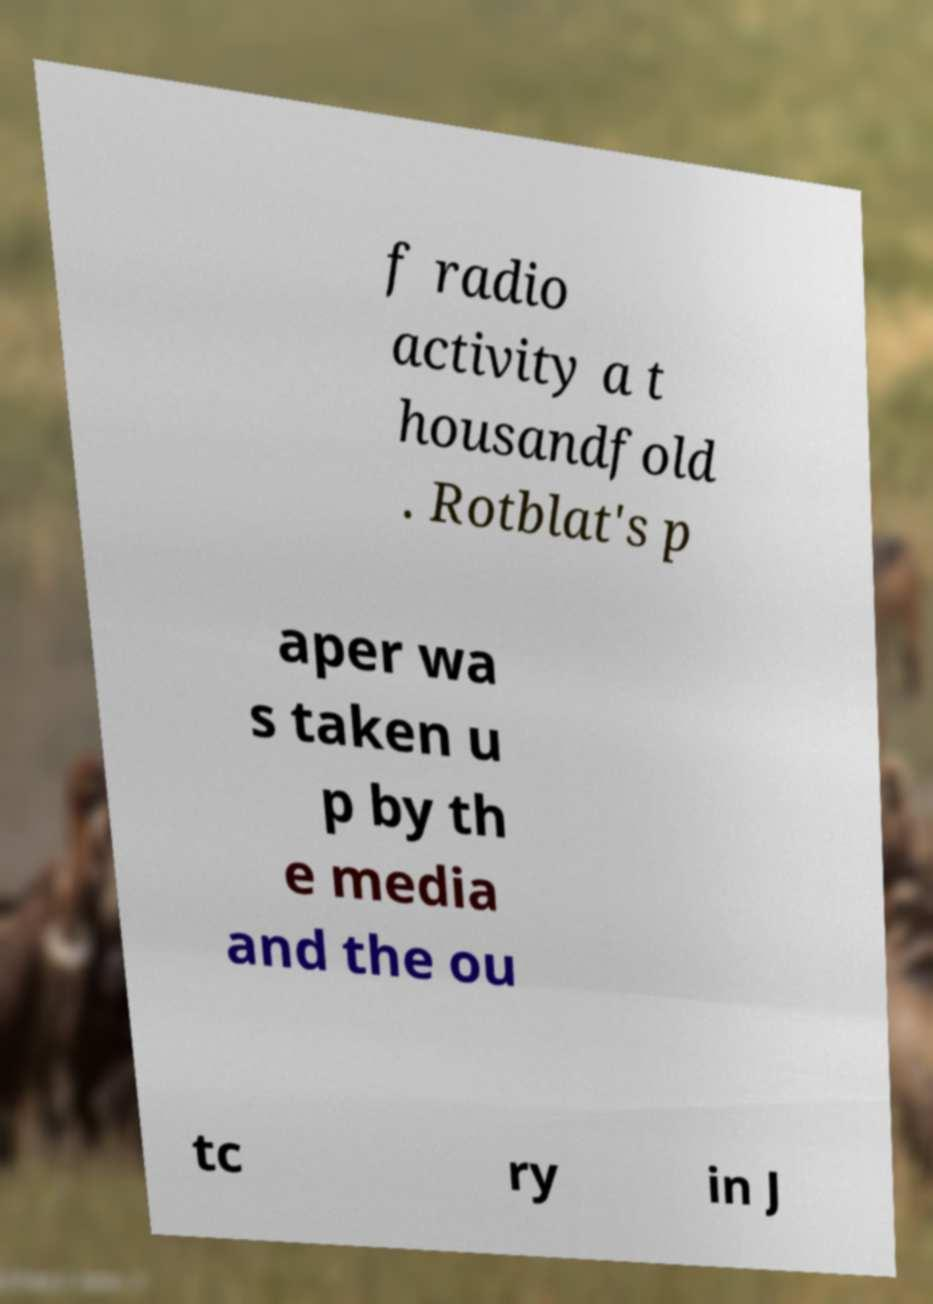Please identify and transcribe the text found in this image. f radio activity a t housandfold . Rotblat's p aper wa s taken u p by th e media and the ou tc ry in J 